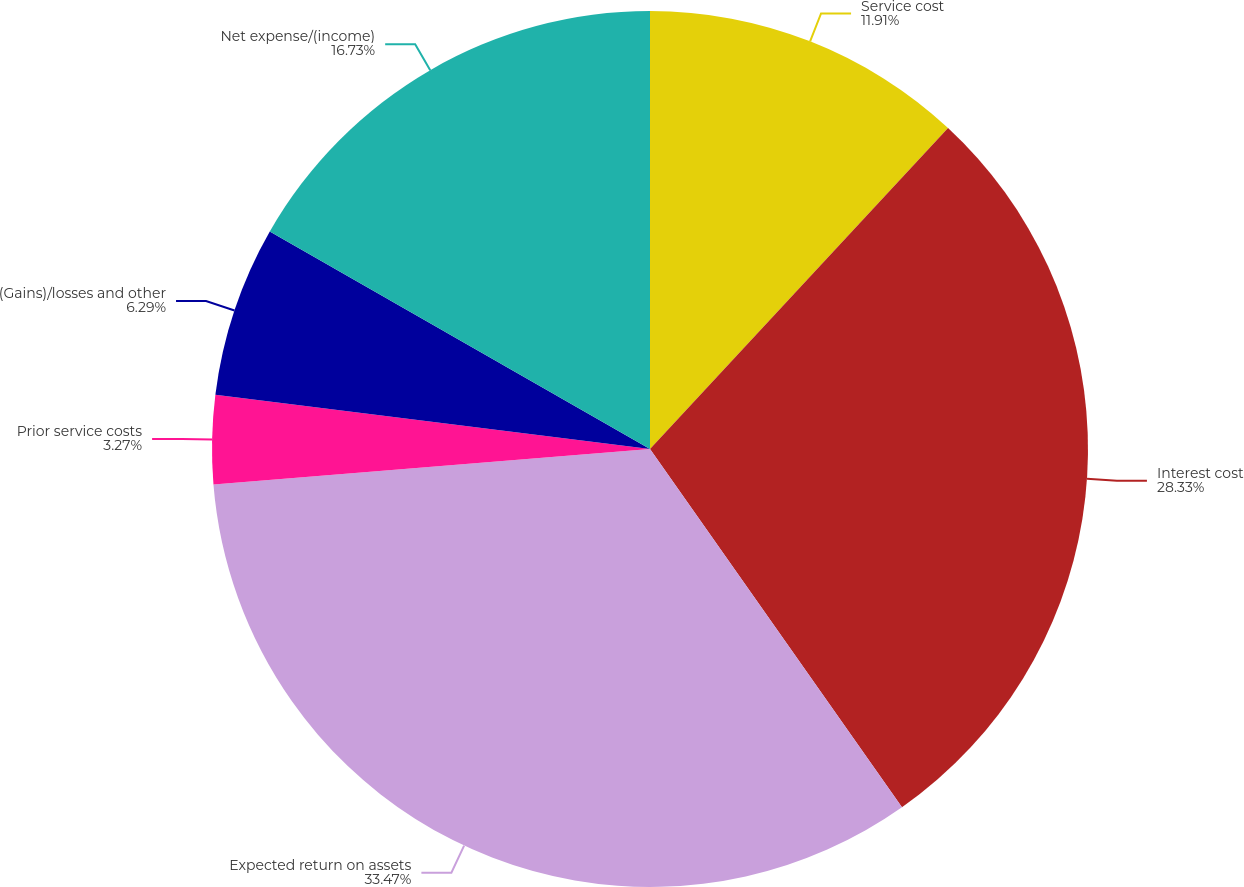Convert chart to OTSL. <chart><loc_0><loc_0><loc_500><loc_500><pie_chart><fcel>Service cost<fcel>Interest cost<fcel>Expected return on assets<fcel>Prior service costs<fcel>(Gains)/losses and other<fcel>Net expense/(income)<nl><fcel>11.91%<fcel>28.33%<fcel>33.46%<fcel>3.27%<fcel>6.29%<fcel>16.73%<nl></chart> 